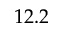Convert formula to latex. <formula><loc_0><loc_0><loc_500><loc_500>1 2 . 2</formula> 